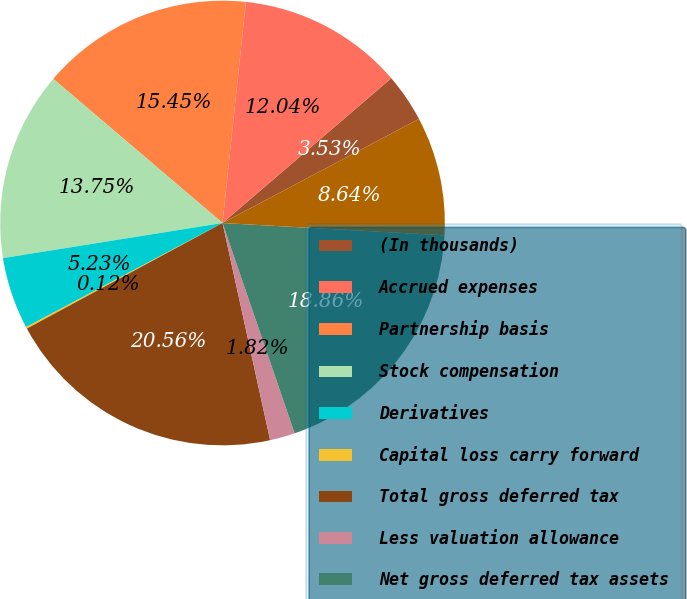Convert chart. <chart><loc_0><loc_0><loc_500><loc_500><pie_chart><fcel>(In thousands)<fcel>Accrued expenses<fcel>Partnership basis<fcel>Stock compensation<fcel>Derivatives<fcel>Capital loss carry forward<fcel>Total gross deferred tax<fcel>Less valuation allowance<fcel>Net gross deferred tax assets<fcel>Prepaid expenses<nl><fcel>3.53%<fcel>12.04%<fcel>15.45%<fcel>13.75%<fcel>5.23%<fcel>0.12%<fcel>20.56%<fcel>1.82%<fcel>18.86%<fcel>8.64%<nl></chart> 